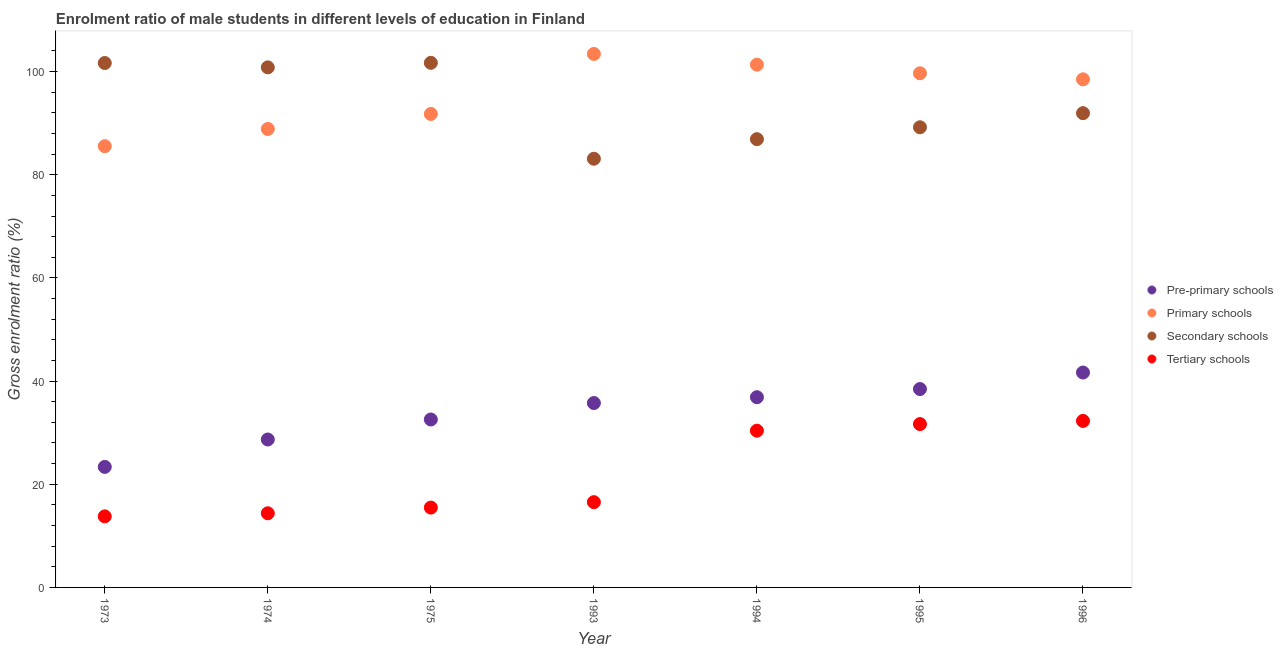How many different coloured dotlines are there?
Ensure brevity in your answer.  4. Is the number of dotlines equal to the number of legend labels?
Offer a very short reply. Yes. What is the gross enrolment ratio(female) in primary schools in 1993?
Offer a terse response. 103.41. Across all years, what is the maximum gross enrolment ratio(female) in pre-primary schools?
Your answer should be compact. 41.65. Across all years, what is the minimum gross enrolment ratio(female) in tertiary schools?
Offer a very short reply. 13.78. In which year was the gross enrolment ratio(female) in primary schools minimum?
Keep it short and to the point. 1973. What is the total gross enrolment ratio(female) in secondary schools in the graph?
Keep it short and to the point. 655.28. What is the difference between the gross enrolment ratio(female) in primary schools in 1975 and that in 1994?
Your response must be concise. -9.56. What is the difference between the gross enrolment ratio(female) in tertiary schools in 1973 and the gross enrolment ratio(female) in secondary schools in 1996?
Ensure brevity in your answer.  -78.16. What is the average gross enrolment ratio(female) in tertiary schools per year?
Keep it short and to the point. 22.07. In the year 1974, what is the difference between the gross enrolment ratio(female) in tertiary schools and gross enrolment ratio(female) in pre-primary schools?
Your response must be concise. -14.3. In how many years, is the gross enrolment ratio(female) in primary schools greater than 96 %?
Offer a terse response. 4. What is the ratio of the gross enrolment ratio(female) in secondary schools in 1973 to that in 1995?
Your answer should be compact. 1.14. What is the difference between the highest and the second highest gross enrolment ratio(female) in secondary schools?
Your answer should be very brief. 0.04. What is the difference between the highest and the lowest gross enrolment ratio(female) in secondary schools?
Give a very brief answer. 18.59. Is it the case that in every year, the sum of the gross enrolment ratio(female) in pre-primary schools and gross enrolment ratio(female) in tertiary schools is greater than the sum of gross enrolment ratio(female) in secondary schools and gross enrolment ratio(female) in primary schools?
Provide a short and direct response. No. Is the gross enrolment ratio(female) in secondary schools strictly greater than the gross enrolment ratio(female) in tertiary schools over the years?
Give a very brief answer. Yes. How many years are there in the graph?
Your answer should be very brief. 7. What is the difference between two consecutive major ticks on the Y-axis?
Your answer should be compact. 20. Does the graph contain grids?
Offer a terse response. No. Where does the legend appear in the graph?
Your answer should be compact. Center right. What is the title of the graph?
Provide a succinct answer. Enrolment ratio of male students in different levels of education in Finland. What is the label or title of the X-axis?
Your answer should be very brief. Year. What is the label or title of the Y-axis?
Make the answer very short. Gross enrolment ratio (%). What is the Gross enrolment ratio (%) in Pre-primary schools in 1973?
Ensure brevity in your answer.  23.36. What is the Gross enrolment ratio (%) in Primary schools in 1973?
Your answer should be very brief. 85.54. What is the Gross enrolment ratio (%) in Secondary schools in 1973?
Ensure brevity in your answer.  101.66. What is the Gross enrolment ratio (%) in Tertiary schools in 1973?
Your answer should be compact. 13.78. What is the Gross enrolment ratio (%) of Pre-primary schools in 1974?
Provide a short and direct response. 28.68. What is the Gross enrolment ratio (%) of Primary schools in 1974?
Offer a terse response. 88.87. What is the Gross enrolment ratio (%) in Secondary schools in 1974?
Your answer should be compact. 100.81. What is the Gross enrolment ratio (%) of Tertiary schools in 1974?
Give a very brief answer. 14.37. What is the Gross enrolment ratio (%) in Pre-primary schools in 1975?
Provide a succinct answer. 32.56. What is the Gross enrolment ratio (%) in Primary schools in 1975?
Offer a very short reply. 91.78. What is the Gross enrolment ratio (%) of Secondary schools in 1975?
Provide a succinct answer. 101.69. What is the Gross enrolment ratio (%) in Tertiary schools in 1975?
Ensure brevity in your answer.  15.48. What is the Gross enrolment ratio (%) of Pre-primary schools in 1993?
Ensure brevity in your answer.  35.74. What is the Gross enrolment ratio (%) of Primary schools in 1993?
Make the answer very short. 103.41. What is the Gross enrolment ratio (%) in Secondary schools in 1993?
Provide a succinct answer. 83.1. What is the Gross enrolment ratio (%) in Tertiary schools in 1993?
Your answer should be compact. 16.53. What is the Gross enrolment ratio (%) of Pre-primary schools in 1994?
Your response must be concise. 36.87. What is the Gross enrolment ratio (%) in Primary schools in 1994?
Offer a very short reply. 101.34. What is the Gross enrolment ratio (%) in Secondary schools in 1994?
Your answer should be very brief. 86.89. What is the Gross enrolment ratio (%) of Tertiary schools in 1994?
Your answer should be very brief. 30.38. What is the Gross enrolment ratio (%) in Pre-primary schools in 1995?
Provide a short and direct response. 38.46. What is the Gross enrolment ratio (%) of Primary schools in 1995?
Make the answer very short. 99.67. What is the Gross enrolment ratio (%) in Secondary schools in 1995?
Offer a terse response. 89.2. What is the Gross enrolment ratio (%) of Tertiary schools in 1995?
Your response must be concise. 31.66. What is the Gross enrolment ratio (%) in Pre-primary schools in 1996?
Offer a terse response. 41.65. What is the Gross enrolment ratio (%) in Primary schools in 1996?
Your response must be concise. 98.5. What is the Gross enrolment ratio (%) in Secondary schools in 1996?
Make the answer very short. 91.93. What is the Gross enrolment ratio (%) in Tertiary schools in 1996?
Provide a short and direct response. 32.28. Across all years, what is the maximum Gross enrolment ratio (%) of Pre-primary schools?
Your answer should be compact. 41.65. Across all years, what is the maximum Gross enrolment ratio (%) in Primary schools?
Your response must be concise. 103.41. Across all years, what is the maximum Gross enrolment ratio (%) in Secondary schools?
Make the answer very short. 101.69. Across all years, what is the maximum Gross enrolment ratio (%) of Tertiary schools?
Your answer should be very brief. 32.28. Across all years, what is the minimum Gross enrolment ratio (%) in Pre-primary schools?
Make the answer very short. 23.36. Across all years, what is the minimum Gross enrolment ratio (%) of Primary schools?
Your answer should be compact. 85.54. Across all years, what is the minimum Gross enrolment ratio (%) in Secondary schools?
Your answer should be very brief. 83.1. Across all years, what is the minimum Gross enrolment ratio (%) in Tertiary schools?
Keep it short and to the point. 13.78. What is the total Gross enrolment ratio (%) of Pre-primary schools in the graph?
Make the answer very short. 237.32. What is the total Gross enrolment ratio (%) in Primary schools in the graph?
Ensure brevity in your answer.  669.11. What is the total Gross enrolment ratio (%) of Secondary schools in the graph?
Provide a short and direct response. 655.28. What is the total Gross enrolment ratio (%) in Tertiary schools in the graph?
Provide a short and direct response. 154.48. What is the difference between the Gross enrolment ratio (%) in Pre-primary schools in 1973 and that in 1974?
Your response must be concise. -5.31. What is the difference between the Gross enrolment ratio (%) of Primary schools in 1973 and that in 1974?
Your answer should be very brief. -3.33. What is the difference between the Gross enrolment ratio (%) in Secondary schools in 1973 and that in 1974?
Offer a very short reply. 0.84. What is the difference between the Gross enrolment ratio (%) in Tertiary schools in 1973 and that in 1974?
Provide a short and direct response. -0.6. What is the difference between the Gross enrolment ratio (%) of Pre-primary schools in 1973 and that in 1975?
Make the answer very short. -9.19. What is the difference between the Gross enrolment ratio (%) in Primary schools in 1973 and that in 1975?
Your answer should be compact. -6.24. What is the difference between the Gross enrolment ratio (%) of Secondary schools in 1973 and that in 1975?
Ensure brevity in your answer.  -0.04. What is the difference between the Gross enrolment ratio (%) in Tertiary schools in 1973 and that in 1975?
Offer a terse response. -1.7. What is the difference between the Gross enrolment ratio (%) of Pre-primary schools in 1973 and that in 1993?
Offer a very short reply. -12.38. What is the difference between the Gross enrolment ratio (%) in Primary schools in 1973 and that in 1993?
Provide a short and direct response. -17.87. What is the difference between the Gross enrolment ratio (%) in Secondary schools in 1973 and that in 1993?
Provide a succinct answer. 18.56. What is the difference between the Gross enrolment ratio (%) in Tertiary schools in 1973 and that in 1993?
Make the answer very short. -2.75. What is the difference between the Gross enrolment ratio (%) of Pre-primary schools in 1973 and that in 1994?
Offer a terse response. -13.51. What is the difference between the Gross enrolment ratio (%) in Primary schools in 1973 and that in 1994?
Provide a succinct answer. -15.8. What is the difference between the Gross enrolment ratio (%) of Secondary schools in 1973 and that in 1994?
Give a very brief answer. 14.76. What is the difference between the Gross enrolment ratio (%) of Tertiary schools in 1973 and that in 1994?
Make the answer very short. -16.61. What is the difference between the Gross enrolment ratio (%) of Pre-primary schools in 1973 and that in 1995?
Your answer should be compact. -15.09. What is the difference between the Gross enrolment ratio (%) of Primary schools in 1973 and that in 1995?
Keep it short and to the point. -14.13. What is the difference between the Gross enrolment ratio (%) of Secondary schools in 1973 and that in 1995?
Your answer should be very brief. 12.45. What is the difference between the Gross enrolment ratio (%) in Tertiary schools in 1973 and that in 1995?
Provide a succinct answer. -17.89. What is the difference between the Gross enrolment ratio (%) of Pre-primary schools in 1973 and that in 1996?
Your response must be concise. -18.29. What is the difference between the Gross enrolment ratio (%) in Primary schools in 1973 and that in 1996?
Make the answer very short. -12.96. What is the difference between the Gross enrolment ratio (%) of Secondary schools in 1973 and that in 1996?
Provide a succinct answer. 9.72. What is the difference between the Gross enrolment ratio (%) in Tertiary schools in 1973 and that in 1996?
Offer a terse response. -18.5. What is the difference between the Gross enrolment ratio (%) in Pre-primary schools in 1974 and that in 1975?
Your answer should be compact. -3.88. What is the difference between the Gross enrolment ratio (%) of Primary schools in 1974 and that in 1975?
Make the answer very short. -2.91. What is the difference between the Gross enrolment ratio (%) in Secondary schools in 1974 and that in 1975?
Provide a succinct answer. -0.88. What is the difference between the Gross enrolment ratio (%) of Tertiary schools in 1974 and that in 1975?
Your answer should be very brief. -1.1. What is the difference between the Gross enrolment ratio (%) in Pre-primary schools in 1974 and that in 1993?
Make the answer very short. -7.07. What is the difference between the Gross enrolment ratio (%) of Primary schools in 1974 and that in 1993?
Keep it short and to the point. -14.54. What is the difference between the Gross enrolment ratio (%) in Secondary schools in 1974 and that in 1993?
Provide a succinct answer. 17.71. What is the difference between the Gross enrolment ratio (%) of Tertiary schools in 1974 and that in 1993?
Provide a succinct answer. -2.15. What is the difference between the Gross enrolment ratio (%) in Pre-primary schools in 1974 and that in 1994?
Keep it short and to the point. -8.2. What is the difference between the Gross enrolment ratio (%) of Primary schools in 1974 and that in 1994?
Your response must be concise. -12.47. What is the difference between the Gross enrolment ratio (%) in Secondary schools in 1974 and that in 1994?
Ensure brevity in your answer.  13.92. What is the difference between the Gross enrolment ratio (%) in Tertiary schools in 1974 and that in 1994?
Your response must be concise. -16.01. What is the difference between the Gross enrolment ratio (%) in Pre-primary schools in 1974 and that in 1995?
Your answer should be very brief. -9.78. What is the difference between the Gross enrolment ratio (%) of Primary schools in 1974 and that in 1995?
Give a very brief answer. -10.79. What is the difference between the Gross enrolment ratio (%) in Secondary schools in 1974 and that in 1995?
Provide a succinct answer. 11.61. What is the difference between the Gross enrolment ratio (%) in Tertiary schools in 1974 and that in 1995?
Your answer should be compact. -17.29. What is the difference between the Gross enrolment ratio (%) in Pre-primary schools in 1974 and that in 1996?
Give a very brief answer. -12.98. What is the difference between the Gross enrolment ratio (%) of Primary schools in 1974 and that in 1996?
Provide a short and direct response. -9.62. What is the difference between the Gross enrolment ratio (%) of Secondary schools in 1974 and that in 1996?
Provide a short and direct response. 8.88. What is the difference between the Gross enrolment ratio (%) of Tertiary schools in 1974 and that in 1996?
Offer a very short reply. -17.9. What is the difference between the Gross enrolment ratio (%) of Pre-primary schools in 1975 and that in 1993?
Offer a very short reply. -3.19. What is the difference between the Gross enrolment ratio (%) of Primary schools in 1975 and that in 1993?
Offer a terse response. -11.63. What is the difference between the Gross enrolment ratio (%) of Secondary schools in 1975 and that in 1993?
Offer a terse response. 18.59. What is the difference between the Gross enrolment ratio (%) in Tertiary schools in 1975 and that in 1993?
Make the answer very short. -1.05. What is the difference between the Gross enrolment ratio (%) in Pre-primary schools in 1975 and that in 1994?
Your answer should be very brief. -4.32. What is the difference between the Gross enrolment ratio (%) in Primary schools in 1975 and that in 1994?
Your answer should be very brief. -9.56. What is the difference between the Gross enrolment ratio (%) of Secondary schools in 1975 and that in 1994?
Offer a terse response. 14.8. What is the difference between the Gross enrolment ratio (%) in Tertiary schools in 1975 and that in 1994?
Keep it short and to the point. -14.91. What is the difference between the Gross enrolment ratio (%) of Pre-primary schools in 1975 and that in 1995?
Offer a very short reply. -5.9. What is the difference between the Gross enrolment ratio (%) of Primary schools in 1975 and that in 1995?
Your answer should be compact. -7.88. What is the difference between the Gross enrolment ratio (%) in Secondary schools in 1975 and that in 1995?
Offer a terse response. 12.49. What is the difference between the Gross enrolment ratio (%) in Tertiary schools in 1975 and that in 1995?
Keep it short and to the point. -16.19. What is the difference between the Gross enrolment ratio (%) in Pre-primary schools in 1975 and that in 1996?
Your answer should be very brief. -9.1. What is the difference between the Gross enrolment ratio (%) of Primary schools in 1975 and that in 1996?
Your response must be concise. -6.71. What is the difference between the Gross enrolment ratio (%) of Secondary schools in 1975 and that in 1996?
Provide a short and direct response. 9.76. What is the difference between the Gross enrolment ratio (%) in Tertiary schools in 1975 and that in 1996?
Make the answer very short. -16.8. What is the difference between the Gross enrolment ratio (%) in Pre-primary schools in 1993 and that in 1994?
Make the answer very short. -1.13. What is the difference between the Gross enrolment ratio (%) in Primary schools in 1993 and that in 1994?
Your response must be concise. 2.08. What is the difference between the Gross enrolment ratio (%) in Secondary schools in 1993 and that in 1994?
Provide a succinct answer. -3.79. What is the difference between the Gross enrolment ratio (%) in Tertiary schools in 1993 and that in 1994?
Make the answer very short. -13.86. What is the difference between the Gross enrolment ratio (%) in Pre-primary schools in 1993 and that in 1995?
Provide a short and direct response. -2.71. What is the difference between the Gross enrolment ratio (%) in Primary schools in 1993 and that in 1995?
Your answer should be compact. 3.75. What is the difference between the Gross enrolment ratio (%) in Secondary schools in 1993 and that in 1995?
Provide a short and direct response. -6.1. What is the difference between the Gross enrolment ratio (%) of Tertiary schools in 1993 and that in 1995?
Make the answer very short. -15.14. What is the difference between the Gross enrolment ratio (%) in Pre-primary schools in 1993 and that in 1996?
Keep it short and to the point. -5.91. What is the difference between the Gross enrolment ratio (%) of Primary schools in 1993 and that in 1996?
Ensure brevity in your answer.  4.92. What is the difference between the Gross enrolment ratio (%) in Secondary schools in 1993 and that in 1996?
Offer a terse response. -8.83. What is the difference between the Gross enrolment ratio (%) of Tertiary schools in 1993 and that in 1996?
Provide a short and direct response. -15.75. What is the difference between the Gross enrolment ratio (%) in Pre-primary schools in 1994 and that in 1995?
Provide a succinct answer. -1.59. What is the difference between the Gross enrolment ratio (%) of Primary schools in 1994 and that in 1995?
Offer a very short reply. 1.67. What is the difference between the Gross enrolment ratio (%) of Secondary schools in 1994 and that in 1995?
Make the answer very short. -2.31. What is the difference between the Gross enrolment ratio (%) of Tertiary schools in 1994 and that in 1995?
Give a very brief answer. -1.28. What is the difference between the Gross enrolment ratio (%) of Pre-primary schools in 1994 and that in 1996?
Keep it short and to the point. -4.78. What is the difference between the Gross enrolment ratio (%) of Primary schools in 1994 and that in 1996?
Offer a terse response. 2.84. What is the difference between the Gross enrolment ratio (%) in Secondary schools in 1994 and that in 1996?
Keep it short and to the point. -5.04. What is the difference between the Gross enrolment ratio (%) in Tertiary schools in 1994 and that in 1996?
Offer a terse response. -1.89. What is the difference between the Gross enrolment ratio (%) in Pre-primary schools in 1995 and that in 1996?
Give a very brief answer. -3.2. What is the difference between the Gross enrolment ratio (%) in Primary schools in 1995 and that in 1996?
Provide a succinct answer. 1.17. What is the difference between the Gross enrolment ratio (%) in Secondary schools in 1995 and that in 1996?
Provide a succinct answer. -2.73. What is the difference between the Gross enrolment ratio (%) of Tertiary schools in 1995 and that in 1996?
Your response must be concise. -0.61. What is the difference between the Gross enrolment ratio (%) of Pre-primary schools in 1973 and the Gross enrolment ratio (%) of Primary schools in 1974?
Keep it short and to the point. -65.51. What is the difference between the Gross enrolment ratio (%) of Pre-primary schools in 1973 and the Gross enrolment ratio (%) of Secondary schools in 1974?
Offer a terse response. -77.45. What is the difference between the Gross enrolment ratio (%) in Pre-primary schools in 1973 and the Gross enrolment ratio (%) in Tertiary schools in 1974?
Provide a succinct answer. 8.99. What is the difference between the Gross enrolment ratio (%) of Primary schools in 1973 and the Gross enrolment ratio (%) of Secondary schools in 1974?
Provide a short and direct response. -15.27. What is the difference between the Gross enrolment ratio (%) of Primary schools in 1973 and the Gross enrolment ratio (%) of Tertiary schools in 1974?
Provide a succinct answer. 71.17. What is the difference between the Gross enrolment ratio (%) of Secondary schools in 1973 and the Gross enrolment ratio (%) of Tertiary schools in 1974?
Offer a terse response. 87.28. What is the difference between the Gross enrolment ratio (%) of Pre-primary schools in 1973 and the Gross enrolment ratio (%) of Primary schools in 1975?
Keep it short and to the point. -68.42. What is the difference between the Gross enrolment ratio (%) in Pre-primary schools in 1973 and the Gross enrolment ratio (%) in Secondary schools in 1975?
Ensure brevity in your answer.  -78.33. What is the difference between the Gross enrolment ratio (%) in Pre-primary schools in 1973 and the Gross enrolment ratio (%) in Tertiary schools in 1975?
Your answer should be compact. 7.89. What is the difference between the Gross enrolment ratio (%) in Primary schools in 1973 and the Gross enrolment ratio (%) in Secondary schools in 1975?
Keep it short and to the point. -16.15. What is the difference between the Gross enrolment ratio (%) of Primary schools in 1973 and the Gross enrolment ratio (%) of Tertiary schools in 1975?
Provide a short and direct response. 70.06. What is the difference between the Gross enrolment ratio (%) of Secondary schools in 1973 and the Gross enrolment ratio (%) of Tertiary schools in 1975?
Provide a short and direct response. 86.18. What is the difference between the Gross enrolment ratio (%) in Pre-primary schools in 1973 and the Gross enrolment ratio (%) in Primary schools in 1993?
Ensure brevity in your answer.  -80.05. What is the difference between the Gross enrolment ratio (%) in Pre-primary schools in 1973 and the Gross enrolment ratio (%) in Secondary schools in 1993?
Make the answer very short. -59.74. What is the difference between the Gross enrolment ratio (%) in Pre-primary schools in 1973 and the Gross enrolment ratio (%) in Tertiary schools in 1993?
Make the answer very short. 6.83. What is the difference between the Gross enrolment ratio (%) in Primary schools in 1973 and the Gross enrolment ratio (%) in Secondary schools in 1993?
Keep it short and to the point. 2.44. What is the difference between the Gross enrolment ratio (%) in Primary schools in 1973 and the Gross enrolment ratio (%) in Tertiary schools in 1993?
Offer a very short reply. 69.01. What is the difference between the Gross enrolment ratio (%) in Secondary schools in 1973 and the Gross enrolment ratio (%) in Tertiary schools in 1993?
Provide a succinct answer. 85.13. What is the difference between the Gross enrolment ratio (%) in Pre-primary schools in 1973 and the Gross enrolment ratio (%) in Primary schools in 1994?
Your answer should be compact. -77.98. What is the difference between the Gross enrolment ratio (%) of Pre-primary schools in 1973 and the Gross enrolment ratio (%) of Secondary schools in 1994?
Provide a succinct answer. -63.53. What is the difference between the Gross enrolment ratio (%) of Pre-primary schools in 1973 and the Gross enrolment ratio (%) of Tertiary schools in 1994?
Provide a succinct answer. -7.02. What is the difference between the Gross enrolment ratio (%) of Primary schools in 1973 and the Gross enrolment ratio (%) of Secondary schools in 1994?
Your answer should be very brief. -1.35. What is the difference between the Gross enrolment ratio (%) of Primary schools in 1973 and the Gross enrolment ratio (%) of Tertiary schools in 1994?
Offer a terse response. 55.16. What is the difference between the Gross enrolment ratio (%) of Secondary schools in 1973 and the Gross enrolment ratio (%) of Tertiary schools in 1994?
Make the answer very short. 71.27. What is the difference between the Gross enrolment ratio (%) of Pre-primary schools in 1973 and the Gross enrolment ratio (%) of Primary schools in 1995?
Your answer should be very brief. -76.3. What is the difference between the Gross enrolment ratio (%) in Pre-primary schools in 1973 and the Gross enrolment ratio (%) in Secondary schools in 1995?
Keep it short and to the point. -65.84. What is the difference between the Gross enrolment ratio (%) of Pre-primary schools in 1973 and the Gross enrolment ratio (%) of Tertiary schools in 1995?
Keep it short and to the point. -8.3. What is the difference between the Gross enrolment ratio (%) in Primary schools in 1973 and the Gross enrolment ratio (%) in Secondary schools in 1995?
Ensure brevity in your answer.  -3.66. What is the difference between the Gross enrolment ratio (%) in Primary schools in 1973 and the Gross enrolment ratio (%) in Tertiary schools in 1995?
Your answer should be very brief. 53.88. What is the difference between the Gross enrolment ratio (%) in Secondary schools in 1973 and the Gross enrolment ratio (%) in Tertiary schools in 1995?
Give a very brief answer. 69.99. What is the difference between the Gross enrolment ratio (%) in Pre-primary schools in 1973 and the Gross enrolment ratio (%) in Primary schools in 1996?
Make the answer very short. -75.13. What is the difference between the Gross enrolment ratio (%) in Pre-primary schools in 1973 and the Gross enrolment ratio (%) in Secondary schools in 1996?
Offer a very short reply. -68.57. What is the difference between the Gross enrolment ratio (%) of Pre-primary schools in 1973 and the Gross enrolment ratio (%) of Tertiary schools in 1996?
Make the answer very short. -8.92. What is the difference between the Gross enrolment ratio (%) in Primary schools in 1973 and the Gross enrolment ratio (%) in Secondary schools in 1996?
Ensure brevity in your answer.  -6.39. What is the difference between the Gross enrolment ratio (%) of Primary schools in 1973 and the Gross enrolment ratio (%) of Tertiary schools in 1996?
Your answer should be very brief. 53.26. What is the difference between the Gross enrolment ratio (%) of Secondary schools in 1973 and the Gross enrolment ratio (%) of Tertiary schools in 1996?
Ensure brevity in your answer.  69.38. What is the difference between the Gross enrolment ratio (%) of Pre-primary schools in 1974 and the Gross enrolment ratio (%) of Primary schools in 1975?
Your response must be concise. -63.1. What is the difference between the Gross enrolment ratio (%) of Pre-primary schools in 1974 and the Gross enrolment ratio (%) of Secondary schools in 1975?
Provide a succinct answer. -73.02. What is the difference between the Gross enrolment ratio (%) in Pre-primary schools in 1974 and the Gross enrolment ratio (%) in Tertiary schools in 1975?
Keep it short and to the point. 13.2. What is the difference between the Gross enrolment ratio (%) in Primary schools in 1974 and the Gross enrolment ratio (%) in Secondary schools in 1975?
Give a very brief answer. -12.82. What is the difference between the Gross enrolment ratio (%) of Primary schools in 1974 and the Gross enrolment ratio (%) of Tertiary schools in 1975?
Your response must be concise. 73.39. What is the difference between the Gross enrolment ratio (%) in Secondary schools in 1974 and the Gross enrolment ratio (%) in Tertiary schools in 1975?
Offer a very short reply. 85.33. What is the difference between the Gross enrolment ratio (%) in Pre-primary schools in 1974 and the Gross enrolment ratio (%) in Primary schools in 1993?
Make the answer very short. -74.74. What is the difference between the Gross enrolment ratio (%) of Pre-primary schools in 1974 and the Gross enrolment ratio (%) of Secondary schools in 1993?
Your answer should be compact. -54.42. What is the difference between the Gross enrolment ratio (%) in Pre-primary schools in 1974 and the Gross enrolment ratio (%) in Tertiary schools in 1993?
Your response must be concise. 12.15. What is the difference between the Gross enrolment ratio (%) in Primary schools in 1974 and the Gross enrolment ratio (%) in Secondary schools in 1993?
Provide a succinct answer. 5.77. What is the difference between the Gross enrolment ratio (%) in Primary schools in 1974 and the Gross enrolment ratio (%) in Tertiary schools in 1993?
Ensure brevity in your answer.  72.34. What is the difference between the Gross enrolment ratio (%) of Secondary schools in 1974 and the Gross enrolment ratio (%) of Tertiary schools in 1993?
Make the answer very short. 84.28. What is the difference between the Gross enrolment ratio (%) of Pre-primary schools in 1974 and the Gross enrolment ratio (%) of Primary schools in 1994?
Your answer should be very brief. -72.66. What is the difference between the Gross enrolment ratio (%) of Pre-primary schools in 1974 and the Gross enrolment ratio (%) of Secondary schools in 1994?
Your answer should be compact. -58.22. What is the difference between the Gross enrolment ratio (%) of Pre-primary schools in 1974 and the Gross enrolment ratio (%) of Tertiary schools in 1994?
Your response must be concise. -1.71. What is the difference between the Gross enrolment ratio (%) in Primary schools in 1974 and the Gross enrolment ratio (%) in Secondary schools in 1994?
Keep it short and to the point. 1.98. What is the difference between the Gross enrolment ratio (%) in Primary schools in 1974 and the Gross enrolment ratio (%) in Tertiary schools in 1994?
Provide a short and direct response. 58.49. What is the difference between the Gross enrolment ratio (%) of Secondary schools in 1974 and the Gross enrolment ratio (%) of Tertiary schools in 1994?
Give a very brief answer. 70.43. What is the difference between the Gross enrolment ratio (%) in Pre-primary schools in 1974 and the Gross enrolment ratio (%) in Primary schools in 1995?
Give a very brief answer. -70.99. What is the difference between the Gross enrolment ratio (%) in Pre-primary schools in 1974 and the Gross enrolment ratio (%) in Secondary schools in 1995?
Keep it short and to the point. -60.52. What is the difference between the Gross enrolment ratio (%) of Pre-primary schools in 1974 and the Gross enrolment ratio (%) of Tertiary schools in 1995?
Keep it short and to the point. -2.99. What is the difference between the Gross enrolment ratio (%) in Primary schools in 1974 and the Gross enrolment ratio (%) in Secondary schools in 1995?
Give a very brief answer. -0.33. What is the difference between the Gross enrolment ratio (%) in Primary schools in 1974 and the Gross enrolment ratio (%) in Tertiary schools in 1995?
Your answer should be compact. 57.21. What is the difference between the Gross enrolment ratio (%) in Secondary schools in 1974 and the Gross enrolment ratio (%) in Tertiary schools in 1995?
Your answer should be compact. 69.15. What is the difference between the Gross enrolment ratio (%) in Pre-primary schools in 1974 and the Gross enrolment ratio (%) in Primary schools in 1996?
Offer a very short reply. -69.82. What is the difference between the Gross enrolment ratio (%) of Pre-primary schools in 1974 and the Gross enrolment ratio (%) of Secondary schools in 1996?
Provide a succinct answer. -63.26. What is the difference between the Gross enrolment ratio (%) of Pre-primary schools in 1974 and the Gross enrolment ratio (%) of Tertiary schools in 1996?
Provide a short and direct response. -3.6. What is the difference between the Gross enrolment ratio (%) in Primary schools in 1974 and the Gross enrolment ratio (%) in Secondary schools in 1996?
Your response must be concise. -3.06. What is the difference between the Gross enrolment ratio (%) in Primary schools in 1974 and the Gross enrolment ratio (%) in Tertiary schools in 1996?
Keep it short and to the point. 56.59. What is the difference between the Gross enrolment ratio (%) in Secondary schools in 1974 and the Gross enrolment ratio (%) in Tertiary schools in 1996?
Provide a short and direct response. 68.53. What is the difference between the Gross enrolment ratio (%) of Pre-primary schools in 1975 and the Gross enrolment ratio (%) of Primary schools in 1993?
Keep it short and to the point. -70.86. What is the difference between the Gross enrolment ratio (%) in Pre-primary schools in 1975 and the Gross enrolment ratio (%) in Secondary schools in 1993?
Provide a succinct answer. -50.54. What is the difference between the Gross enrolment ratio (%) in Pre-primary schools in 1975 and the Gross enrolment ratio (%) in Tertiary schools in 1993?
Make the answer very short. 16.03. What is the difference between the Gross enrolment ratio (%) of Primary schools in 1975 and the Gross enrolment ratio (%) of Secondary schools in 1993?
Ensure brevity in your answer.  8.68. What is the difference between the Gross enrolment ratio (%) in Primary schools in 1975 and the Gross enrolment ratio (%) in Tertiary schools in 1993?
Offer a very short reply. 75.25. What is the difference between the Gross enrolment ratio (%) of Secondary schools in 1975 and the Gross enrolment ratio (%) of Tertiary schools in 1993?
Provide a short and direct response. 85.16. What is the difference between the Gross enrolment ratio (%) in Pre-primary schools in 1975 and the Gross enrolment ratio (%) in Primary schools in 1994?
Provide a short and direct response. -68.78. What is the difference between the Gross enrolment ratio (%) of Pre-primary schools in 1975 and the Gross enrolment ratio (%) of Secondary schools in 1994?
Provide a succinct answer. -54.34. What is the difference between the Gross enrolment ratio (%) in Pre-primary schools in 1975 and the Gross enrolment ratio (%) in Tertiary schools in 1994?
Ensure brevity in your answer.  2.17. What is the difference between the Gross enrolment ratio (%) in Primary schools in 1975 and the Gross enrolment ratio (%) in Secondary schools in 1994?
Keep it short and to the point. 4.89. What is the difference between the Gross enrolment ratio (%) in Primary schools in 1975 and the Gross enrolment ratio (%) in Tertiary schools in 1994?
Your response must be concise. 61.4. What is the difference between the Gross enrolment ratio (%) of Secondary schools in 1975 and the Gross enrolment ratio (%) of Tertiary schools in 1994?
Keep it short and to the point. 71.31. What is the difference between the Gross enrolment ratio (%) of Pre-primary schools in 1975 and the Gross enrolment ratio (%) of Primary schools in 1995?
Provide a succinct answer. -67.11. What is the difference between the Gross enrolment ratio (%) of Pre-primary schools in 1975 and the Gross enrolment ratio (%) of Secondary schools in 1995?
Provide a succinct answer. -56.64. What is the difference between the Gross enrolment ratio (%) in Pre-primary schools in 1975 and the Gross enrolment ratio (%) in Tertiary schools in 1995?
Your answer should be very brief. 0.89. What is the difference between the Gross enrolment ratio (%) of Primary schools in 1975 and the Gross enrolment ratio (%) of Secondary schools in 1995?
Keep it short and to the point. 2.58. What is the difference between the Gross enrolment ratio (%) in Primary schools in 1975 and the Gross enrolment ratio (%) in Tertiary schools in 1995?
Ensure brevity in your answer.  60.12. What is the difference between the Gross enrolment ratio (%) in Secondary schools in 1975 and the Gross enrolment ratio (%) in Tertiary schools in 1995?
Provide a short and direct response. 70.03. What is the difference between the Gross enrolment ratio (%) of Pre-primary schools in 1975 and the Gross enrolment ratio (%) of Primary schools in 1996?
Give a very brief answer. -65.94. What is the difference between the Gross enrolment ratio (%) in Pre-primary schools in 1975 and the Gross enrolment ratio (%) in Secondary schools in 1996?
Provide a short and direct response. -59.38. What is the difference between the Gross enrolment ratio (%) of Pre-primary schools in 1975 and the Gross enrolment ratio (%) of Tertiary schools in 1996?
Your answer should be very brief. 0.28. What is the difference between the Gross enrolment ratio (%) of Primary schools in 1975 and the Gross enrolment ratio (%) of Secondary schools in 1996?
Keep it short and to the point. -0.15. What is the difference between the Gross enrolment ratio (%) in Primary schools in 1975 and the Gross enrolment ratio (%) in Tertiary schools in 1996?
Offer a very short reply. 59.5. What is the difference between the Gross enrolment ratio (%) of Secondary schools in 1975 and the Gross enrolment ratio (%) of Tertiary schools in 1996?
Your answer should be compact. 69.41. What is the difference between the Gross enrolment ratio (%) of Pre-primary schools in 1993 and the Gross enrolment ratio (%) of Primary schools in 1994?
Provide a succinct answer. -65.6. What is the difference between the Gross enrolment ratio (%) in Pre-primary schools in 1993 and the Gross enrolment ratio (%) in Secondary schools in 1994?
Make the answer very short. -51.15. What is the difference between the Gross enrolment ratio (%) of Pre-primary schools in 1993 and the Gross enrolment ratio (%) of Tertiary schools in 1994?
Your response must be concise. 5.36. What is the difference between the Gross enrolment ratio (%) of Primary schools in 1993 and the Gross enrolment ratio (%) of Secondary schools in 1994?
Your answer should be very brief. 16.52. What is the difference between the Gross enrolment ratio (%) in Primary schools in 1993 and the Gross enrolment ratio (%) in Tertiary schools in 1994?
Give a very brief answer. 73.03. What is the difference between the Gross enrolment ratio (%) of Secondary schools in 1993 and the Gross enrolment ratio (%) of Tertiary schools in 1994?
Offer a very short reply. 52.71. What is the difference between the Gross enrolment ratio (%) of Pre-primary schools in 1993 and the Gross enrolment ratio (%) of Primary schools in 1995?
Your answer should be compact. -63.92. What is the difference between the Gross enrolment ratio (%) of Pre-primary schools in 1993 and the Gross enrolment ratio (%) of Secondary schools in 1995?
Ensure brevity in your answer.  -53.46. What is the difference between the Gross enrolment ratio (%) in Pre-primary schools in 1993 and the Gross enrolment ratio (%) in Tertiary schools in 1995?
Make the answer very short. 4.08. What is the difference between the Gross enrolment ratio (%) in Primary schools in 1993 and the Gross enrolment ratio (%) in Secondary schools in 1995?
Provide a succinct answer. 14.21. What is the difference between the Gross enrolment ratio (%) in Primary schools in 1993 and the Gross enrolment ratio (%) in Tertiary schools in 1995?
Ensure brevity in your answer.  71.75. What is the difference between the Gross enrolment ratio (%) in Secondary schools in 1993 and the Gross enrolment ratio (%) in Tertiary schools in 1995?
Provide a short and direct response. 51.43. What is the difference between the Gross enrolment ratio (%) of Pre-primary schools in 1993 and the Gross enrolment ratio (%) of Primary schools in 1996?
Your answer should be compact. -62.75. What is the difference between the Gross enrolment ratio (%) of Pre-primary schools in 1993 and the Gross enrolment ratio (%) of Secondary schools in 1996?
Make the answer very short. -56.19. What is the difference between the Gross enrolment ratio (%) of Pre-primary schools in 1993 and the Gross enrolment ratio (%) of Tertiary schools in 1996?
Keep it short and to the point. 3.46. What is the difference between the Gross enrolment ratio (%) of Primary schools in 1993 and the Gross enrolment ratio (%) of Secondary schools in 1996?
Make the answer very short. 11.48. What is the difference between the Gross enrolment ratio (%) in Primary schools in 1993 and the Gross enrolment ratio (%) in Tertiary schools in 1996?
Your answer should be very brief. 71.14. What is the difference between the Gross enrolment ratio (%) in Secondary schools in 1993 and the Gross enrolment ratio (%) in Tertiary schools in 1996?
Provide a short and direct response. 50.82. What is the difference between the Gross enrolment ratio (%) of Pre-primary schools in 1994 and the Gross enrolment ratio (%) of Primary schools in 1995?
Your answer should be compact. -62.79. What is the difference between the Gross enrolment ratio (%) of Pre-primary schools in 1994 and the Gross enrolment ratio (%) of Secondary schools in 1995?
Your answer should be compact. -52.33. What is the difference between the Gross enrolment ratio (%) in Pre-primary schools in 1994 and the Gross enrolment ratio (%) in Tertiary schools in 1995?
Provide a short and direct response. 5.21. What is the difference between the Gross enrolment ratio (%) of Primary schools in 1994 and the Gross enrolment ratio (%) of Secondary schools in 1995?
Ensure brevity in your answer.  12.14. What is the difference between the Gross enrolment ratio (%) of Primary schools in 1994 and the Gross enrolment ratio (%) of Tertiary schools in 1995?
Offer a terse response. 69.67. What is the difference between the Gross enrolment ratio (%) in Secondary schools in 1994 and the Gross enrolment ratio (%) in Tertiary schools in 1995?
Your response must be concise. 55.23. What is the difference between the Gross enrolment ratio (%) in Pre-primary schools in 1994 and the Gross enrolment ratio (%) in Primary schools in 1996?
Your response must be concise. -61.62. What is the difference between the Gross enrolment ratio (%) in Pre-primary schools in 1994 and the Gross enrolment ratio (%) in Secondary schools in 1996?
Provide a short and direct response. -55.06. What is the difference between the Gross enrolment ratio (%) in Pre-primary schools in 1994 and the Gross enrolment ratio (%) in Tertiary schools in 1996?
Give a very brief answer. 4.59. What is the difference between the Gross enrolment ratio (%) in Primary schools in 1994 and the Gross enrolment ratio (%) in Secondary schools in 1996?
Your answer should be compact. 9.41. What is the difference between the Gross enrolment ratio (%) of Primary schools in 1994 and the Gross enrolment ratio (%) of Tertiary schools in 1996?
Offer a terse response. 69.06. What is the difference between the Gross enrolment ratio (%) of Secondary schools in 1994 and the Gross enrolment ratio (%) of Tertiary schools in 1996?
Offer a very short reply. 54.61. What is the difference between the Gross enrolment ratio (%) in Pre-primary schools in 1995 and the Gross enrolment ratio (%) in Primary schools in 1996?
Offer a terse response. -60.04. What is the difference between the Gross enrolment ratio (%) in Pre-primary schools in 1995 and the Gross enrolment ratio (%) in Secondary schools in 1996?
Your answer should be very brief. -53.48. What is the difference between the Gross enrolment ratio (%) of Pre-primary schools in 1995 and the Gross enrolment ratio (%) of Tertiary schools in 1996?
Make the answer very short. 6.18. What is the difference between the Gross enrolment ratio (%) in Primary schools in 1995 and the Gross enrolment ratio (%) in Secondary schools in 1996?
Provide a succinct answer. 7.73. What is the difference between the Gross enrolment ratio (%) of Primary schools in 1995 and the Gross enrolment ratio (%) of Tertiary schools in 1996?
Make the answer very short. 67.39. What is the difference between the Gross enrolment ratio (%) of Secondary schools in 1995 and the Gross enrolment ratio (%) of Tertiary schools in 1996?
Give a very brief answer. 56.92. What is the average Gross enrolment ratio (%) of Pre-primary schools per year?
Provide a succinct answer. 33.9. What is the average Gross enrolment ratio (%) in Primary schools per year?
Ensure brevity in your answer.  95.59. What is the average Gross enrolment ratio (%) in Secondary schools per year?
Your response must be concise. 93.61. What is the average Gross enrolment ratio (%) in Tertiary schools per year?
Your response must be concise. 22.07. In the year 1973, what is the difference between the Gross enrolment ratio (%) of Pre-primary schools and Gross enrolment ratio (%) of Primary schools?
Your answer should be very brief. -62.18. In the year 1973, what is the difference between the Gross enrolment ratio (%) in Pre-primary schools and Gross enrolment ratio (%) in Secondary schools?
Provide a short and direct response. -78.29. In the year 1973, what is the difference between the Gross enrolment ratio (%) of Pre-primary schools and Gross enrolment ratio (%) of Tertiary schools?
Your answer should be compact. 9.59. In the year 1973, what is the difference between the Gross enrolment ratio (%) of Primary schools and Gross enrolment ratio (%) of Secondary schools?
Make the answer very short. -16.12. In the year 1973, what is the difference between the Gross enrolment ratio (%) in Primary schools and Gross enrolment ratio (%) in Tertiary schools?
Your response must be concise. 71.76. In the year 1973, what is the difference between the Gross enrolment ratio (%) of Secondary schools and Gross enrolment ratio (%) of Tertiary schools?
Keep it short and to the point. 87.88. In the year 1974, what is the difference between the Gross enrolment ratio (%) in Pre-primary schools and Gross enrolment ratio (%) in Primary schools?
Provide a succinct answer. -60.2. In the year 1974, what is the difference between the Gross enrolment ratio (%) in Pre-primary schools and Gross enrolment ratio (%) in Secondary schools?
Give a very brief answer. -72.14. In the year 1974, what is the difference between the Gross enrolment ratio (%) of Pre-primary schools and Gross enrolment ratio (%) of Tertiary schools?
Provide a short and direct response. 14.3. In the year 1974, what is the difference between the Gross enrolment ratio (%) in Primary schools and Gross enrolment ratio (%) in Secondary schools?
Provide a succinct answer. -11.94. In the year 1974, what is the difference between the Gross enrolment ratio (%) in Primary schools and Gross enrolment ratio (%) in Tertiary schools?
Provide a succinct answer. 74.5. In the year 1974, what is the difference between the Gross enrolment ratio (%) in Secondary schools and Gross enrolment ratio (%) in Tertiary schools?
Provide a short and direct response. 86.44. In the year 1975, what is the difference between the Gross enrolment ratio (%) in Pre-primary schools and Gross enrolment ratio (%) in Primary schools?
Provide a short and direct response. -59.23. In the year 1975, what is the difference between the Gross enrolment ratio (%) in Pre-primary schools and Gross enrolment ratio (%) in Secondary schools?
Your response must be concise. -69.14. In the year 1975, what is the difference between the Gross enrolment ratio (%) of Pre-primary schools and Gross enrolment ratio (%) of Tertiary schools?
Keep it short and to the point. 17.08. In the year 1975, what is the difference between the Gross enrolment ratio (%) of Primary schools and Gross enrolment ratio (%) of Secondary schools?
Provide a short and direct response. -9.91. In the year 1975, what is the difference between the Gross enrolment ratio (%) of Primary schools and Gross enrolment ratio (%) of Tertiary schools?
Ensure brevity in your answer.  76.3. In the year 1975, what is the difference between the Gross enrolment ratio (%) of Secondary schools and Gross enrolment ratio (%) of Tertiary schools?
Your response must be concise. 86.22. In the year 1993, what is the difference between the Gross enrolment ratio (%) of Pre-primary schools and Gross enrolment ratio (%) of Primary schools?
Give a very brief answer. -67.67. In the year 1993, what is the difference between the Gross enrolment ratio (%) in Pre-primary schools and Gross enrolment ratio (%) in Secondary schools?
Ensure brevity in your answer.  -47.36. In the year 1993, what is the difference between the Gross enrolment ratio (%) in Pre-primary schools and Gross enrolment ratio (%) in Tertiary schools?
Make the answer very short. 19.21. In the year 1993, what is the difference between the Gross enrolment ratio (%) in Primary schools and Gross enrolment ratio (%) in Secondary schools?
Offer a terse response. 20.32. In the year 1993, what is the difference between the Gross enrolment ratio (%) of Primary schools and Gross enrolment ratio (%) of Tertiary schools?
Provide a succinct answer. 86.89. In the year 1993, what is the difference between the Gross enrolment ratio (%) of Secondary schools and Gross enrolment ratio (%) of Tertiary schools?
Ensure brevity in your answer.  66.57. In the year 1994, what is the difference between the Gross enrolment ratio (%) of Pre-primary schools and Gross enrolment ratio (%) of Primary schools?
Give a very brief answer. -64.47. In the year 1994, what is the difference between the Gross enrolment ratio (%) of Pre-primary schools and Gross enrolment ratio (%) of Secondary schools?
Offer a very short reply. -50.02. In the year 1994, what is the difference between the Gross enrolment ratio (%) of Pre-primary schools and Gross enrolment ratio (%) of Tertiary schools?
Keep it short and to the point. 6.49. In the year 1994, what is the difference between the Gross enrolment ratio (%) of Primary schools and Gross enrolment ratio (%) of Secondary schools?
Ensure brevity in your answer.  14.45. In the year 1994, what is the difference between the Gross enrolment ratio (%) of Primary schools and Gross enrolment ratio (%) of Tertiary schools?
Your answer should be compact. 70.95. In the year 1994, what is the difference between the Gross enrolment ratio (%) in Secondary schools and Gross enrolment ratio (%) in Tertiary schools?
Give a very brief answer. 56.51. In the year 1995, what is the difference between the Gross enrolment ratio (%) in Pre-primary schools and Gross enrolment ratio (%) in Primary schools?
Provide a short and direct response. -61.21. In the year 1995, what is the difference between the Gross enrolment ratio (%) in Pre-primary schools and Gross enrolment ratio (%) in Secondary schools?
Provide a succinct answer. -50.74. In the year 1995, what is the difference between the Gross enrolment ratio (%) in Pre-primary schools and Gross enrolment ratio (%) in Tertiary schools?
Offer a terse response. 6.79. In the year 1995, what is the difference between the Gross enrolment ratio (%) in Primary schools and Gross enrolment ratio (%) in Secondary schools?
Your response must be concise. 10.46. In the year 1995, what is the difference between the Gross enrolment ratio (%) in Primary schools and Gross enrolment ratio (%) in Tertiary schools?
Your answer should be compact. 68. In the year 1995, what is the difference between the Gross enrolment ratio (%) of Secondary schools and Gross enrolment ratio (%) of Tertiary schools?
Your response must be concise. 57.54. In the year 1996, what is the difference between the Gross enrolment ratio (%) in Pre-primary schools and Gross enrolment ratio (%) in Primary schools?
Make the answer very short. -56.84. In the year 1996, what is the difference between the Gross enrolment ratio (%) in Pre-primary schools and Gross enrolment ratio (%) in Secondary schools?
Offer a terse response. -50.28. In the year 1996, what is the difference between the Gross enrolment ratio (%) in Pre-primary schools and Gross enrolment ratio (%) in Tertiary schools?
Keep it short and to the point. 9.38. In the year 1996, what is the difference between the Gross enrolment ratio (%) in Primary schools and Gross enrolment ratio (%) in Secondary schools?
Offer a very short reply. 6.56. In the year 1996, what is the difference between the Gross enrolment ratio (%) of Primary schools and Gross enrolment ratio (%) of Tertiary schools?
Keep it short and to the point. 66.22. In the year 1996, what is the difference between the Gross enrolment ratio (%) of Secondary schools and Gross enrolment ratio (%) of Tertiary schools?
Offer a very short reply. 59.65. What is the ratio of the Gross enrolment ratio (%) in Pre-primary schools in 1973 to that in 1974?
Ensure brevity in your answer.  0.81. What is the ratio of the Gross enrolment ratio (%) of Primary schools in 1973 to that in 1974?
Ensure brevity in your answer.  0.96. What is the ratio of the Gross enrolment ratio (%) in Secondary schools in 1973 to that in 1974?
Give a very brief answer. 1.01. What is the ratio of the Gross enrolment ratio (%) of Pre-primary schools in 1973 to that in 1975?
Keep it short and to the point. 0.72. What is the ratio of the Gross enrolment ratio (%) of Primary schools in 1973 to that in 1975?
Give a very brief answer. 0.93. What is the ratio of the Gross enrolment ratio (%) in Tertiary schools in 1973 to that in 1975?
Provide a succinct answer. 0.89. What is the ratio of the Gross enrolment ratio (%) of Pre-primary schools in 1973 to that in 1993?
Make the answer very short. 0.65. What is the ratio of the Gross enrolment ratio (%) of Primary schools in 1973 to that in 1993?
Make the answer very short. 0.83. What is the ratio of the Gross enrolment ratio (%) of Secondary schools in 1973 to that in 1993?
Make the answer very short. 1.22. What is the ratio of the Gross enrolment ratio (%) of Tertiary schools in 1973 to that in 1993?
Provide a short and direct response. 0.83. What is the ratio of the Gross enrolment ratio (%) of Pre-primary schools in 1973 to that in 1994?
Your response must be concise. 0.63. What is the ratio of the Gross enrolment ratio (%) of Primary schools in 1973 to that in 1994?
Your response must be concise. 0.84. What is the ratio of the Gross enrolment ratio (%) in Secondary schools in 1973 to that in 1994?
Provide a short and direct response. 1.17. What is the ratio of the Gross enrolment ratio (%) in Tertiary schools in 1973 to that in 1994?
Ensure brevity in your answer.  0.45. What is the ratio of the Gross enrolment ratio (%) of Pre-primary schools in 1973 to that in 1995?
Keep it short and to the point. 0.61. What is the ratio of the Gross enrolment ratio (%) of Primary schools in 1973 to that in 1995?
Your answer should be very brief. 0.86. What is the ratio of the Gross enrolment ratio (%) of Secondary schools in 1973 to that in 1995?
Provide a succinct answer. 1.14. What is the ratio of the Gross enrolment ratio (%) of Tertiary schools in 1973 to that in 1995?
Your response must be concise. 0.43. What is the ratio of the Gross enrolment ratio (%) of Pre-primary schools in 1973 to that in 1996?
Your response must be concise. 0.56. What is the ratio of the Gross enrolment ratio (%) in Primary schools in 1973 to that in 1996?
Keep it short and to the point. 0.87. What is the ratio of the Gross enrolment ratio (%) of Secondary schools in 1973 to that in 1996?
Ensure brevity in your answer.  1.11. What is the ratio of the Gross enrolment ratio (%) in Tertiary schools in 1973 to that in 1996?
Provide a succinct answer. 0.43. What is the ratio of the Gross enrolment ratio (%) in Pre-primary schools in 1974 to that in 1975?
Keep it short and to the point. 0.88. What is the ratio of the Gross enrolment ratio (%) of Primary schools in 1974 to that in 1975?
Make the answer very short. 0.97. What is the ratio of the Gross enrolment ratio (%) of Tertiary schools in 1974 to that in 1975?
Your answer should be compact. 0.93. What is the ratio of the Gross enrolment ratio (%) of Pre-primary schools in 1974 to that in 1993?
Your response must be concise. 0.8. What is the ratio of the Gross enrolment ratio (%) of Primary schools in 1974 to that in 1993?
Provide a succinct answer. 0.86. What is the ratio of the Gross enrolment ratio (%) of Secondary schools in 1974 to that in 1993?
Provide a succinct answer. 1.21. What is the ratio of the Gross enrolment ratio (%) of Tertiary schools in 1974 to that in 1993?
Your answer should be compact. 0.87. What is the ratio of the Gross enrolment ratio (%) of Pre-primary schools in 1974 to that in 1994?
Provide a short and direct response. 0.78. What is the ratio of the Gross enrolment ratio (%) in Primary schools in 1974 to that in 1994?
Your response must be concise. 0.88. What is the ratio of the Gross enrolment ratio (%) of Secondary schools in 1974 to that in 1994?
Provide a short and direct response. 1.16. What is the ratio of the Gross enrolment ratio (%) of Tertiary schools in 1974 to that in 1994?
Offer a very short reply. 0.47. What is the ratio of the Gross enrolment ratio (%) of Pre-primary schools in 1974 to that in 1995?
Ensure brevity in your answer.  0.75. What is the ratio of the Gross enrolment ratio (%) of Primary schools in 1974 to that in 1995?
Offer a very short reply. 0.89. What is the ratio of the Gross enrolment ratio (%) in Secondary schools in 1974 to that in 1995?
Offer a terse response. 1.13. What is the ratio of the Gross enrolment ratio (%) of Tertiary schools in 1974 to that in 1995?
Ensure brevity in your answer.  0.45. What is the ratio of the Gross enrolment ratio (%) of Pre-primary schools in 1974 to that in 1996?
Your answer should be compact. 0.69. What is the ratio of the Gross enrolment ratio (%) in Primary schools in 1974 to that in 1996?
Ensure brevity in your answer.  0.9. What is the ratio of the Gross enrolment ratio (%) in Secondary schools in 1974 to that in 1996?
Your answer should be compact. 1.1. What is the ratio of the Gross enrolment ratio (%) in Tertiary schools in 1974 to that in 1996?
Your answer should be very brief. 0.45. What is the ratio of the Gross enrolment ratio (%) of Pre-primary schools in 1975 to that in 1993?
Provide a succinct answer. 0.91. What is the ratio of the Gross enrolment ratio (%) of Primary schools in 1975 to that in 1993?
Make the answer very short. 0.89. What is the ratio of the Gross enrolment ratio (%) of Secondary schools in 1975 to that in 1993?
Keep it short and to the point. 1.22. What is the ratio of the Gross enrolment ratio (%) in Tertiary schools in 1975 to that in 1993?
Make the answer very short. 0.94. What is the ratio of the Gross enrolment ratio (%) in Pre-primary schools in 1975 to that in 1994?
Keep it short and to the point. 0.88. What is the ratio of the Gross enrolment ratio (%) in Primary schools in 1975 to that in 1994?
Offer a terse response. 0.91. What is the ratio of the Gross enrolment ratio (%) of Secondary schools in 1975 to that in 1994?
Your answer should be compact. 1.17. What is the ratio of the Gross enrolment ratio (%) in Tertiary schools in 1975 to that in 1994?
Your answer should be compact. 0.51. What is the ratio of the Gross enrolment ratio (%) of Pre-primary schools in 1975 to that in 1995?
Make the answer very short. 0.85. What is the ratio of the Gross enrolment ratio (%) of Primary schools in 1975 to that in 1995?
Your response must be concise. 0.92. What is the ratio of the Gross enrolment ratio (%) of Secondary schools in 1975 to that in 1995?
Keep it short and to the point. 1.14. What is the ratio of the Gross enrolment ratio (%) in Tertiary schools in 1975 to that in 1995?
Keep it short and to the point. 0.49. What is the ratio of the Gross enrolment ratio (%) of Pre-primary schools in 1975 to that in 1996?
Keep it short and to the point. 0.78. What is the ratio of the Gross enrolment ratio (%) of Primary schools in 1975 to that in 1996?
Your answer should be very brief. 0.93. What is the ratio of the Gross enrolment ratio (%) in Secondary schools in 1975 to that in 1996?
Give a very brief answer. 1.11. What is the ratio of the Gross enrolment ratio (%) of Tertiary schools in 1975 to that in 1996?
Make the answer very short. 0.48. What is the ratio of the Gross enrolment ratio (%) in Pre-primary schools in 1993 to that in 1994?
Offer a very short reply. 0.97. What is the ratio of the Gross enrolment ratio (%) in Primary schools in 1993 to that in 1994?
Offer a very short reply. 1.02. What is the ratio of the Gross enrolment ratio (%) of Secondary schools in 1993 to that in 1994?
Your response must be concise. 0.96. What is the ratio of the Gross enrolment ratio (%) of Tertiary schools in 1993 to that in 1994?
Provide a succinct answer. 0.54. What is the ratio of the Gross enrolment ratio (%) in Pre-primary schools in 1993 to that in 1995?
Your response must be concise. 0.93. What is the ratio of the Gross enrolment ratio (%) in Primary schools in 1993 to that in 1995?
Make the answer very short. 1.04. What is the ratio of the Gross enrolment ratio (%) of Secondary schools in 1993 to that in 1995?
Your answer should be compact. 0.93. What is the ratio of the Gross enrolment ratio (%) of Tertiary schools in 1993 to that in 1995?
Ensure brevity in your answer.  0.52. What is the ratio of the Gross enrolment ratio (%) of Pre-primary schools in 1993 to that in 1996?
Give a very brief answer. 0.86. What is the ratio of the Gross enrolment ratio (%) in Primary schools in 1993 to that in 1996?
Ensure brevity in your answer.  1.05. What is the ratio of the Gross enrolment ratio (%) in Secondary schools in 1993 to that in 1996?
Your answer should be very brief. 0.9. What is the ratio of the Gross enrolment ratio (%) of Tertiary schools in 1993 to that in 1996?
Your answer should be compact. 0.51. What is the ratio of the Gross enrolment ratio (%) in Pre-primary schools in 1994 to that in 1995?
Ensure brevity in your answer.  0.96. What is the ratio of the Gross enrolment ratio (%) in Primary schools in 1994 to that in 1995?
Your answer should be compact. 1.02. What is the ratio of the Gross enrolment ratio (%) of Secondary schools in 1994 to that in 1995?
Provide a short and direct response. 0.97. What is the ratio of the Gross enrolment ratio (%) in Tertiary schools in 1994 to that in 1995?
Keep it short and to the point. 0.96. What is the ratio of the Gross enrolment ratio (%) of Pre-primary schools in 1994 to that in 1996?
Give a very brief answer. 0.89. What is the ratio of the Gross enrolment ratio (%) of Primary schools in 1994 to that in 1996?
Ensure brevity in your answer.  1.03. What is the ratio of the Gross enrolment ratio (%) in Secondary schools in 1994 to that in 1996?
Make the answer very short. 0.95. What is the ratio of the Gross enrolment ratio (%) in Tertiary schools in 1994 to that in 1996?
Provide a succinct answer. 0.94. What is the ratio of the Gross enrolment ratio (%) of Pre-primary schools in 1995 to that in 1996?
Provide a short and direct response. 0.92. What is the ratio of the Gross enrolment ratio (%) in Primary schools in 1995 to that in 1996?
Keep it short and to the point. 1.01. What is the ratio of the Gross enrolment ratio (%) of Secondary schools in 1995 to that in 1996?
Your answer should be very brief. 0.97. What is the difference between the highest and the second highest Gross enrolment ratio (%) of Pre-primary schools?
Give a very brief answer. 3.2. What is the difference between the highest and the second highest Gross enrolment ratio (%) in Primary schools?
Offer a terse response. 2.08. What is the difference between the highest and the second highest Gross enrolment ratio (%) of Secondary schools?
Provide a succinct answer. 0.04. What is the difference between the highest and the second highest Gross enrolment ratio (%) in Tertiary schools?
Offer a terse response. 0.61. What is the difference between the highest and the lowest Gross enrolment ratio (%) in Pre-primary schools?
Offer a terse response. 18.29. What is the difference between the highest and the lowest Gross enrolment ratio (%) of Primary schools?
Offer a terse response. 17.87. What is the difference between the highest and the lowest Gross enrolment ratio (%) in Secondary schools?
Ensure brevity in your answer.  18.59. What is the difference between the highest and the lowest Gross enrolment ratio (%) in Tertiary schools?
Ensure brevity in your answer.  18.5. 